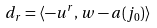<formula> <loc_0><loc_0><loc_500><loc_500>d _ { r } = \langle - u ^ { r } , w - a ( j _ { 0 } ) \rangle</formula> 